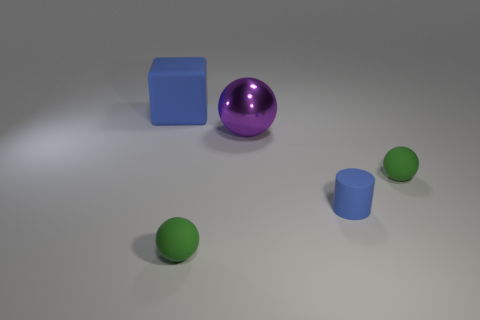What is the color of the large object that is right of the blue object that is behind the small green matte object that is on the right side of the metal thing? The large object situated to the right of the blue cube, which in turn is located behind the small green sphere on the right side of the metal-cast cylindrical shape, exhibits a rich purple hue. 